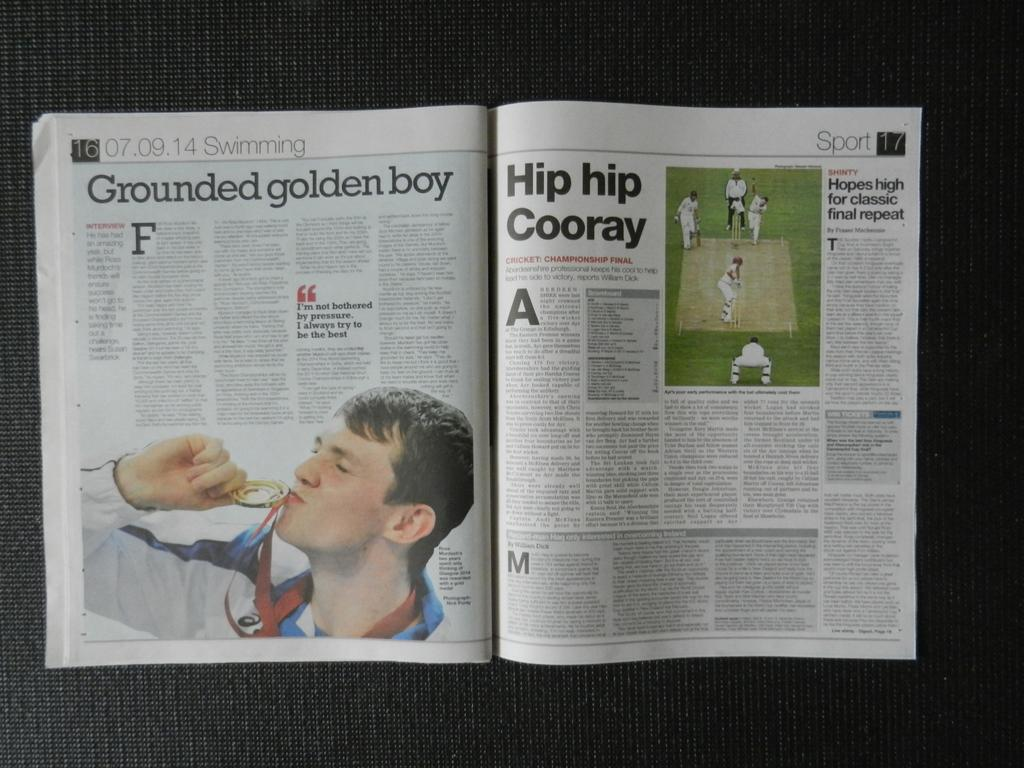What object can be seen in the image? There is a magazine in the image. Can you describe the magazine in more detail? Unfortunately, the provided facts do not offer any additional details about the magazine. What type of coach is featured on the cover of the magazine? There is no coach present on the cover of the magazine, as the provided facts do not mention any specific details about the magazine's content or appearance. 